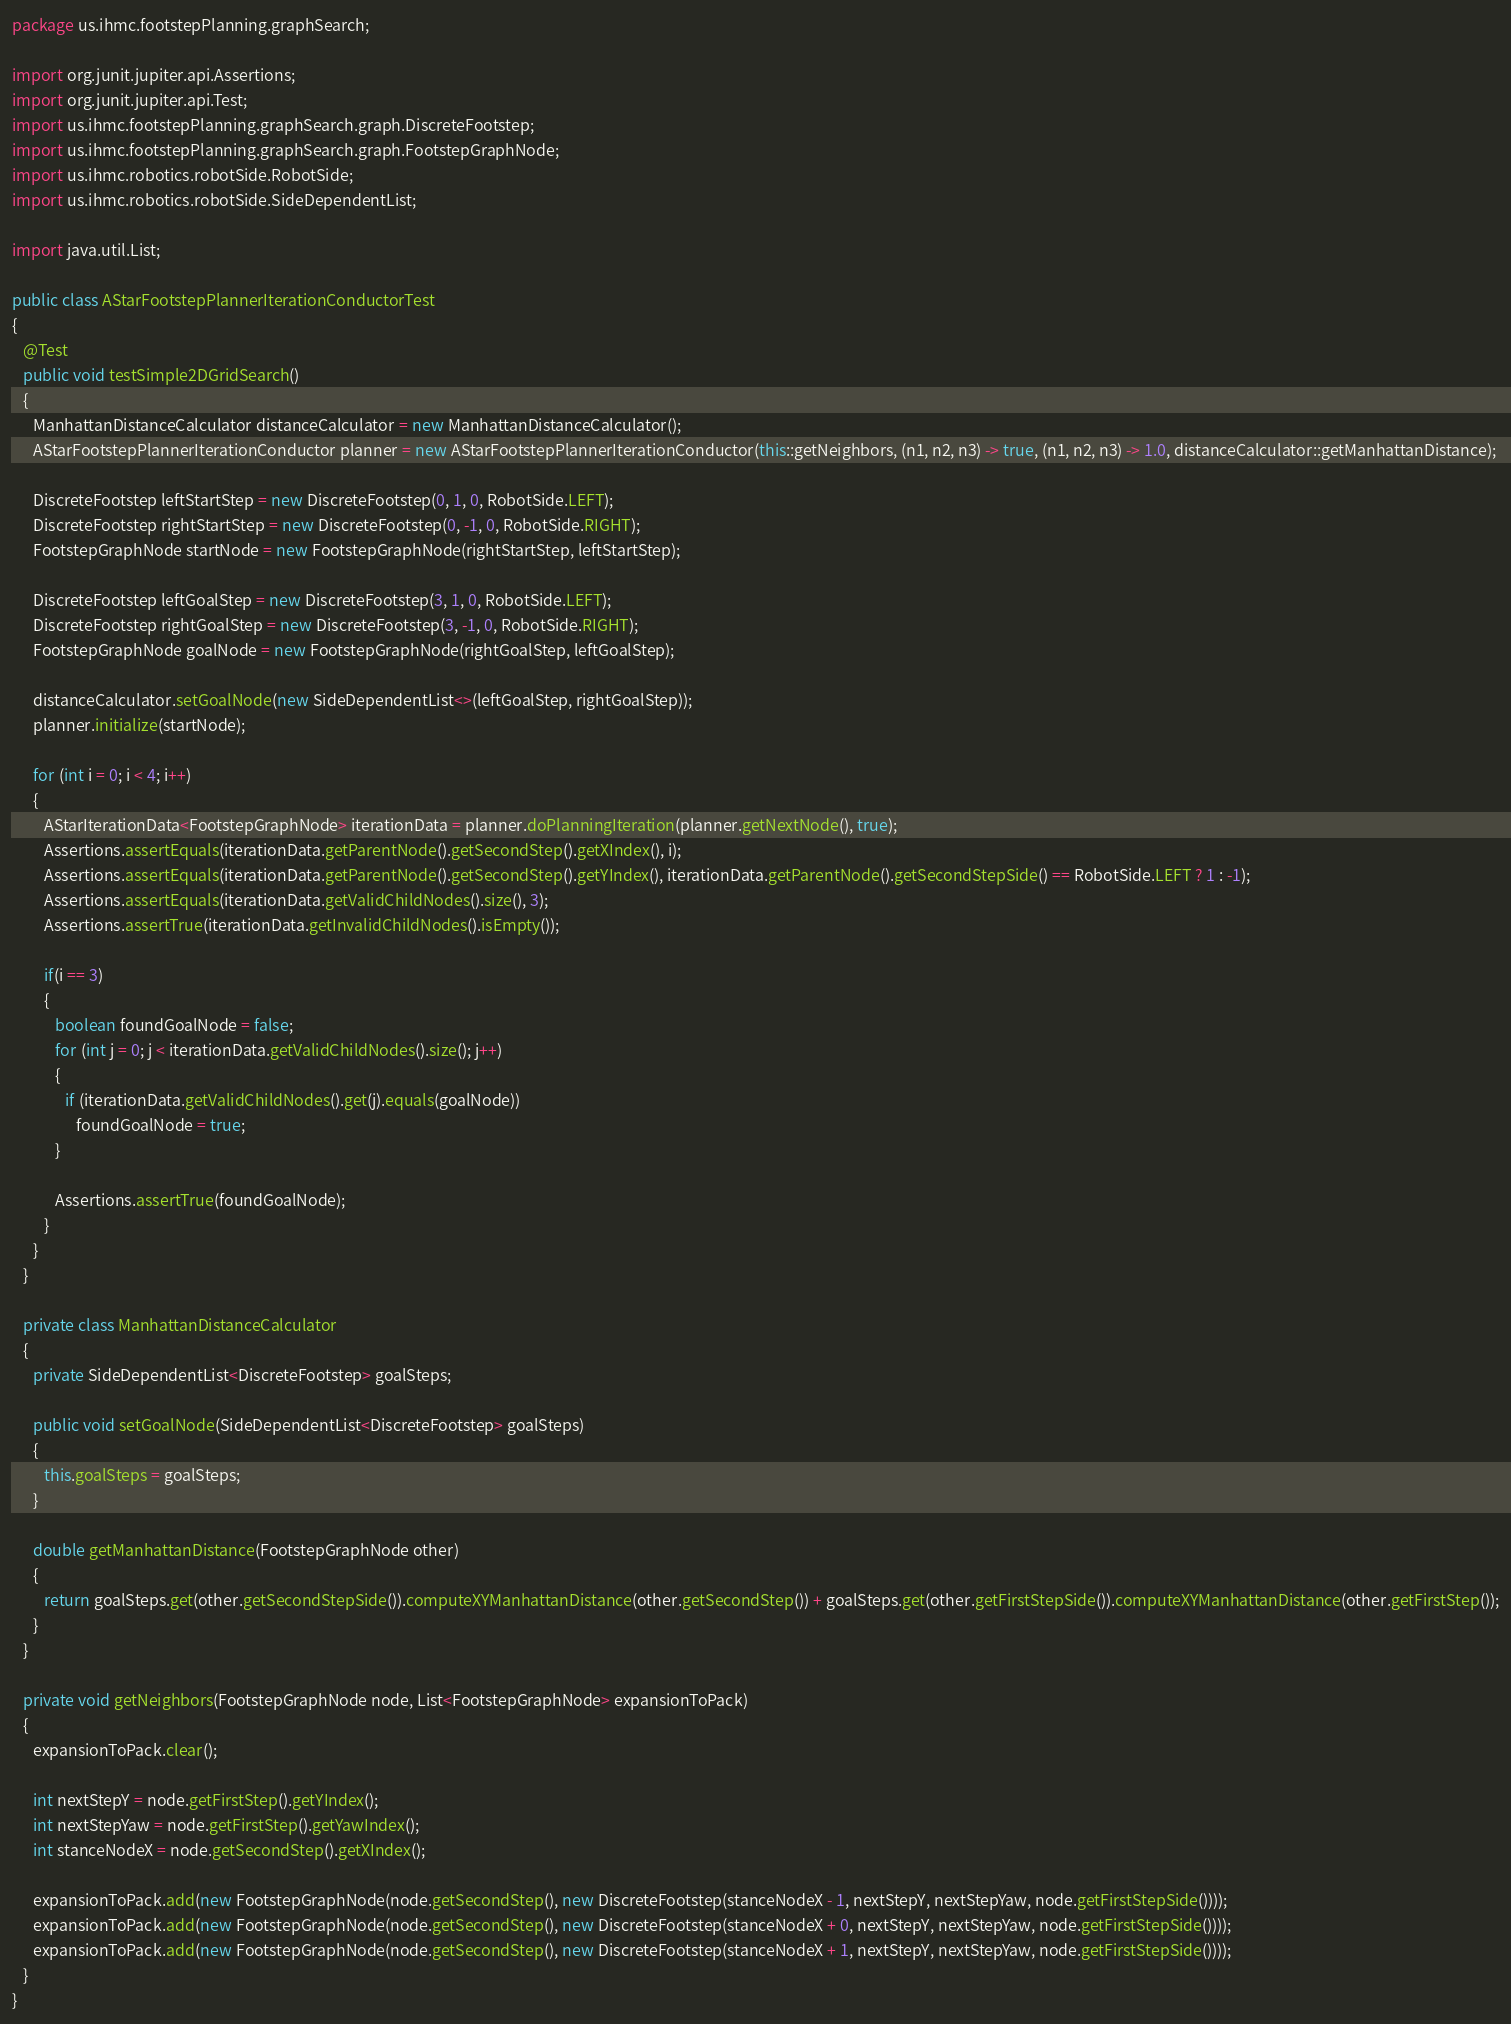<code> <loc_0><loc_0><loc_500><loc_500><_Java_>package us.ihmc.footstepPlanning.graphSearch;

import org.junit.jupiter.api.Assertions;
import org.junit.jupiter.api.Test;
import us.ihmc.footstepPlanning.graphSearch.graph.DiscreteFootstep;
import us.ihmc.footstepPlanning.graphSearch.graph.FootstepGraphNode;
import us.ihmc.robotics.robotSide.RobotSide;
import us.ihmc.robotics.robotSide.SideDependentList;

import java.util.List;

public class AStarFootstepPlannerIterationConductorTest
{
   @Test
   public void testSimple2DGridSearch()
   {
      ManhattanDistanceCalculator distanceCalculator = new ManhattanDistanceCalculator();
      AStarFootstepPlannerIterationConductor planner = new AStarFootstepPlannerIterationConductor(this::getNeighbors, (n1, n2, n3) -> true, (n1, n2, n3) -> 1.0, distanceCalculator::getManhattanDistance);

      DiscreteFootstep leftStartStep = new DiscreteFootstep(0, 1, 0, RobotSide.LEFT);
      DiscreteFootstep rightStartStep = new DiscreteFootstep(0, -1, 0, RobotSide.RIGHT);
      FootstepGraphNode startNode = new FootstepGraphNode(rightStartStep, leftStartStep);

      DiscreteFootstep leftGoalStep = new DiscreteFootstep(3, 1, 0, RobotSide.LEFT);
      DiscreteFootstep rightGoalStep = new DiscreteFootstep(3, -1, 0, RobotSide.RIGHT);
      FootstepGraphNode goalNode = new FootstepGraphNode(rightGoalStep, leftGoalStep);

      distanceCalculator.setGoalNode(new SideDependentList<>(leftGoalStep, rightGoalStep));
      planner.initialize(startNode);

      for (int i = 0; i < 4; i++)
      {
         AStarIterationData<FootstepGraphNode> iterationData = planner.doPlanningIteration(planner.getNextNode(), true);
         Assertions.assertEquals(iterationData.getParentNode().getSecondStep().getXIndex(), i);
         Assertions.assertEquals(iterationData.getParentNode().getSecondStep().getYIndex(), iterationData.getParentNode().getSecondStepSide() == RobotSide.LEFT ? 1 : -1);
         Assertions.assertEquals(iterationData.getValidChildNodes().size(), 3);
         Assertions.assertTrue(iterationData.getInvalidChildNodes().isEmpty());

         if(i == 3)
         {
            boolean foundGoalNode = false;
            for (int j = 0; j < iterationData.getValidChildNodes().size(); j++)
            {
               if (iterationData.getValidChildNodes().get(j).equals(goalNode))
                  foundGoalNode = true;
            }

            Assertions.assertTrue(foundGoalNode);
         }
      }
   }

   private class ManhattanDistanceCalculator
   {
      private SideDependentList<DiscreteFootstep> goalSteps;

      public void setGoalNode(SideDependentList<DiscreteFootstep> goalSteps)
      {
         this.goalSteps = goalSteps;
      }

      double getManhattanDistance(FootstepGraphNode other)
      {
         return goalSteps.get(other.getSecondStepSide()).computeXYManhattanDistance(other.getSecondStep()) + goalSteps.get(other.getFirstStepSide()).computeXYManhattanDistance(other.getFirstStep());
      }
   }

   private void getNeighbors(FootstepGraphNode node, List<FootstepGraphNode> expansionToPack)
   {
      expansionToPack.clear();

      int nextStepY = node.getFirstStep().getYIndex();
      int nextStepYaw = node.getFirstStep().getYawIndex();
      int stanceNodeX = node.getSecondStep().getXIndex();

      expansionToPack.add(new FootstepGraphNode(node.getSecondStep(), new DiscreteFootstep(stanceNodeX - 1, nextStepY, nextStepYaw, node.getFirstStepSide())));
      expansionToPack.add(new FootstepGraphNode(node.getSecondStep(), new DiscreteFootstep(stanceNodeX + 0, nextStepY, nextStepYaw, node.getFirstStepSide())));
      expansionToPack.add(new FootstepGraphNode(node.getSecondStep(), new DiscreteFootstep(stanceNodeX + 1, nextStepY, nextStepYaw, node.getFirstStepSide())));
   }
}

</code> 